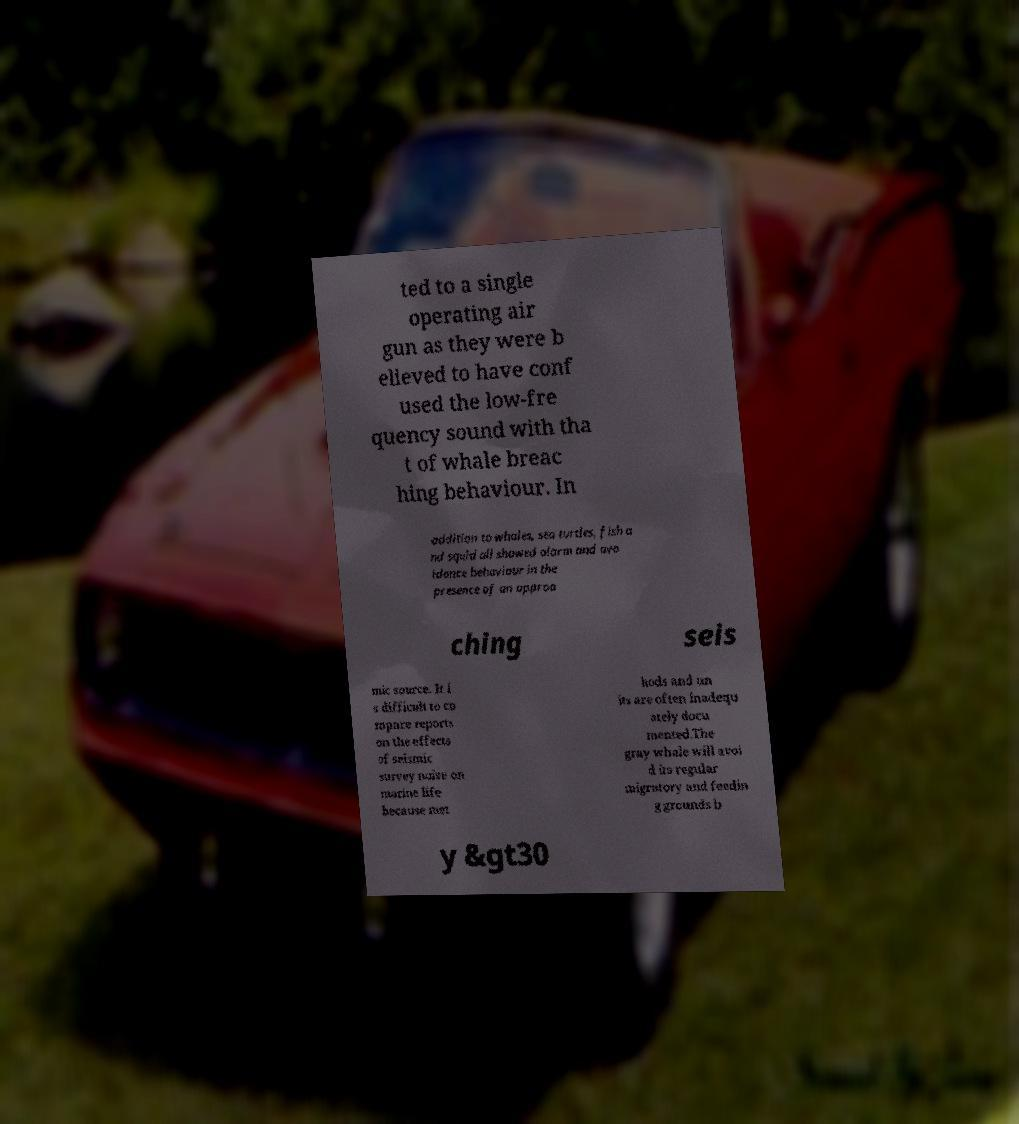Could you extract and type out the text from this image? ted to a single operating air gun as they were b elieved to have conf used the low-fre quency sound with tha t of whale breac hing behaviour. In addition to whales, sea turtles, fish a nd squid all showed alarm and avo idance behaviour in the presence of an approa ching seis mic source. It i s difficult to co mpare reports on the effects of seismic survey noise on marine life because met hods and un its are often inadequ ately docu mented.The gray whale will avoi d its regular migratory and feedin g grounds b y &gt30 